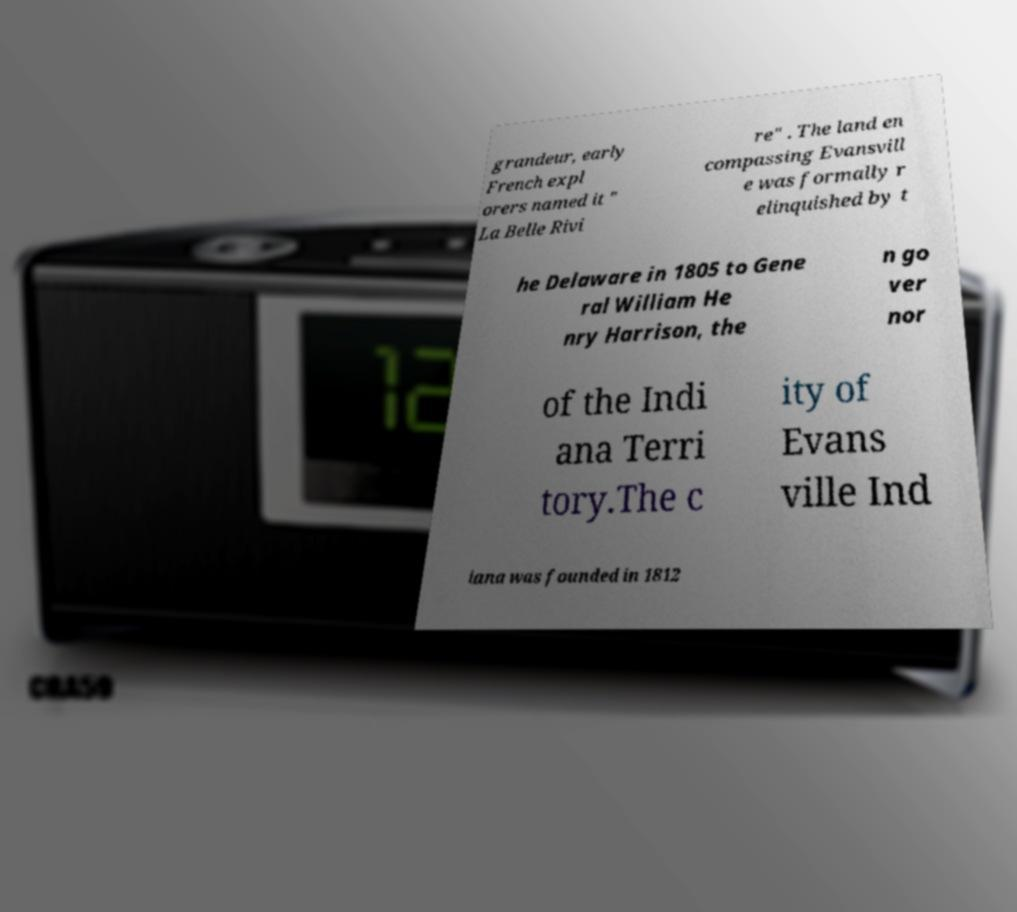There's text embedded in this image that I need extracted. Can you transcribe it verbatim? grandeur, early French expl orers named it " La Belle Rivi re" . The land en compassing Evansvill e was formally r elinquished by t he Delaware in 1805 to Gene ral William He nry Harrison, the n go ver nor of the Indi ana Terri tory.The c ity of Evans ville Ind iana was founded in 1812 